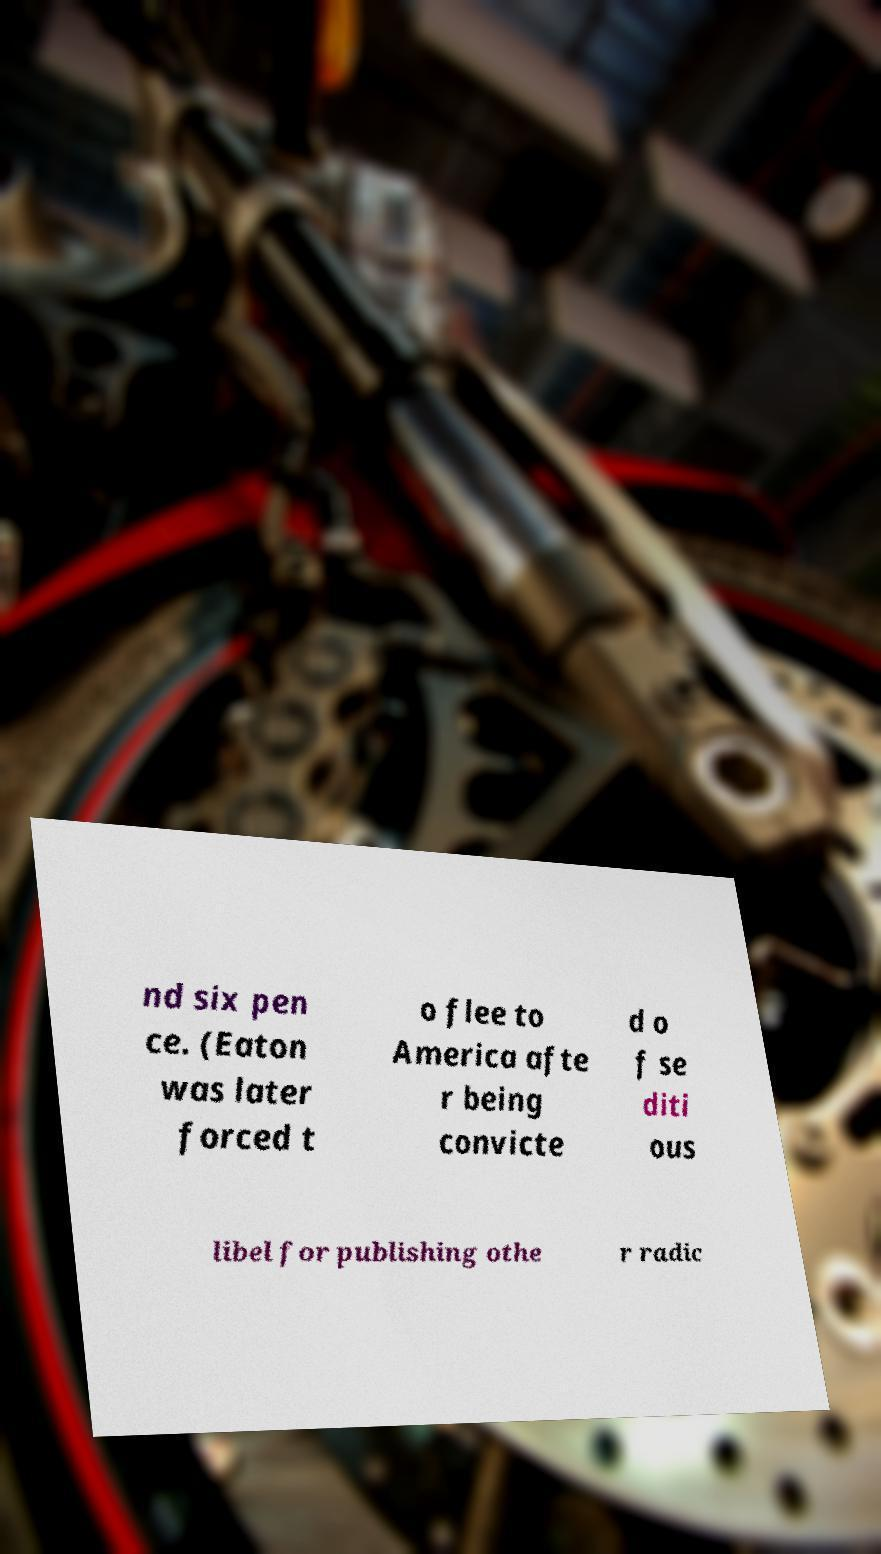Can you read and provide the text displayed in the image?This photo seems to have some interesting text. Can you extract and type it out for me? nd six pen ce. (Eaton was later forced t o flee to America afte r being convicte d o f se diti ous libel for publishing othe r radic 